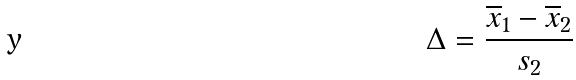<formula> <loc_0><loc_0><loc_500><loc_500>\Delta = \frac { \overline { x } _ { 1 } - \overline { x } _ { 2 } } { s _ { 2 } }</formula> 